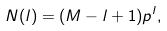Convert formula to latex. <formula><loc_0><loc_0><loc_500><loc_500>N ( l ) = ( M - l + 1 ) p ^ { l } ,</formula> 